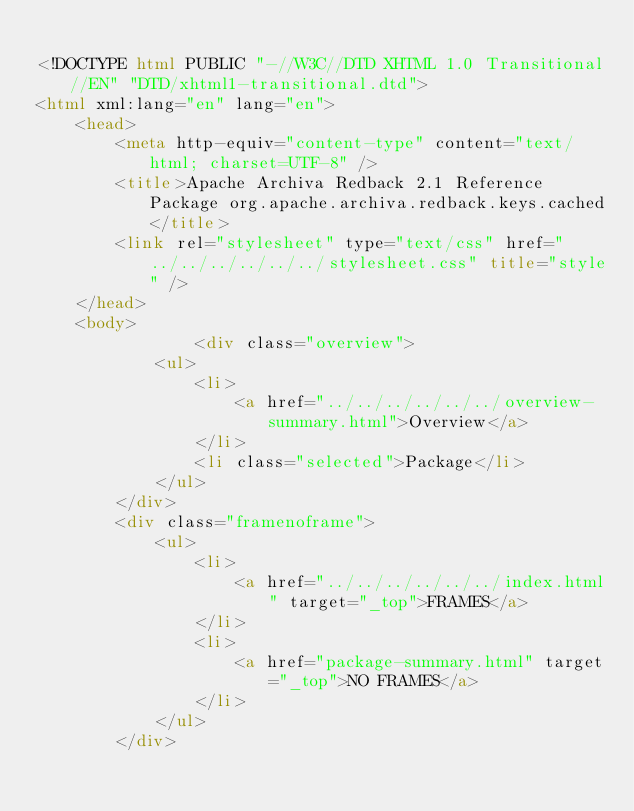<code> <loc_0><loc_0><loc_500><loc_500><_HTML_>
<!DOCTYPE html PUBLIC "-//W3C//DTD XHTML 1.0 Transitional//EN" "DTD/xhtml1-transitional.dtd">
<html xml:lang="en" lang="en">
	<head>
		<meta http-equiv="content-type" content="text/html; charset=UTF-8" />
		<title>Apache Archiva Redback 2.1 Reference Package org.apache.archiva.redback.keys.cached</title>
		<link rel="stylesheet" type="text/css" href="../../../../../../stylesheet.css" title="style" />
	</head>
	<body>
		      	<div class="overview">
        	<ul>
          		<li>
            		<a href="../../../../../../overview-summary.html">Overview</a>
          		</li>
          		<li class="selected">Package</li>
        	</ul>
      	</div>
      	<div class="framenoframe">
        	<ul>
          		<li>
            		<a href="../../../../../../index.html" target="_top">FRAMES</a>
          		</li>
          		<li>
            		<a href="package-summary.html" target="_top">NO FRAMES</a>
          		</li>
        	</ul>
      	</div>
		</code> 